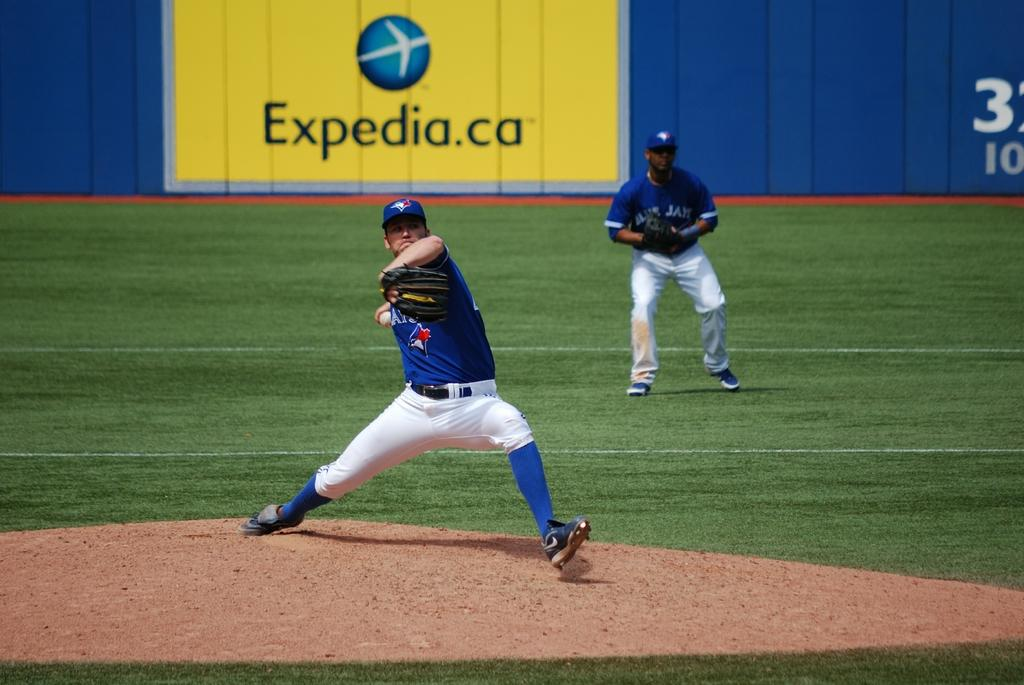<image>
Give a short and clear explanation of the subsequent image. A baseball player is about to pitch the ball and an Expedia ad is behind him on the stadium wall. 